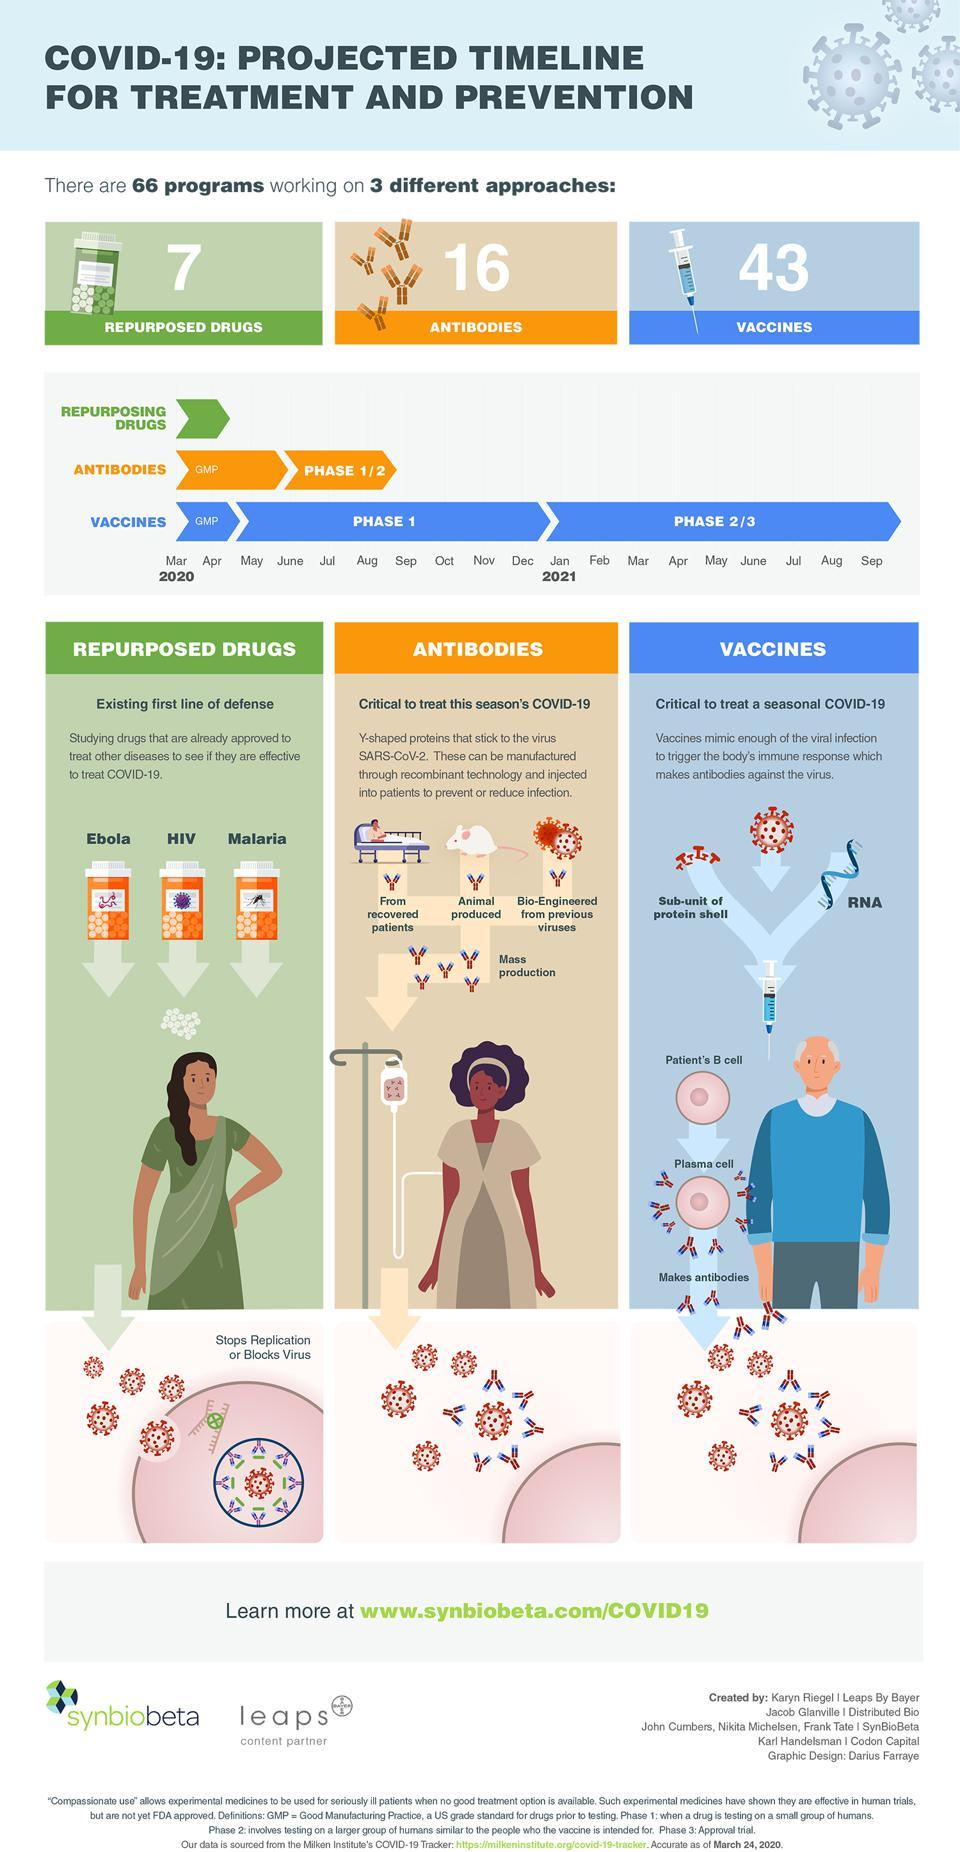Draw attention to some important aspects in this diagram. The development of Y-shaped proteins through recombinant technology can occur in three distinct ways. The method used to develop Y-shaped proteins is recombinant technology. Three potential strategies for addressing COVID-19 include the use of repurposed drugs, antibodies, and vaccines. These approaches aim to both treat and prevent infection by the virus. There are currently 16 antibody-based approaches being developed to treat COVID-19, also known as the coronavirus disease 2019. There are currently 43 vaccine-based approaches being used to treat COVID-19. 